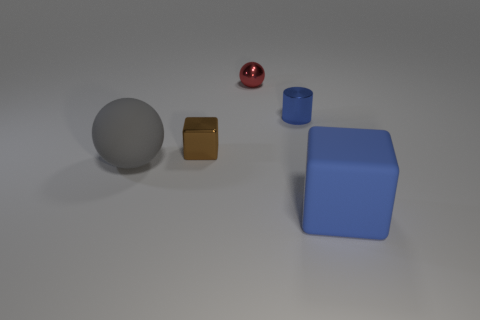Are there more tiny red spheres that are to the right of the red ball than tiny red metal things?
Provide a succinct answer. No. What color is the matte thing on the right side of the big matte object behind the blue rubber thing?
Make the answer very short. Blue. What shape is the gray thing that is the same size as the rubber cube?
Your response must be concise. Sphere. The thing that is the same color as the rubber block is what shape?
Offer a terse response. Cylinder. Are there an equal number of blue things behind the small brown object and large objects?
Your answer should be very brief. No. There is a blue thing in front of the block that is left of the blue object behind the large blue matte thing; what is it made of?
Provide a succinct answer. Rubber. The blue object that is made of the same material as the tiny block is what shape?
Offer a terse response. Cylinder. Are there any other things of the same color as the rubber ball?
Offer a very short reply. No. There is a thing in front of the matte object left of the blue block; what number of metallic objects are behind it?
Your answer should be very brief. 3. How many brown objects are rubber cubes or tiny matte cylinders?
Keep it short and to the point. 0. 